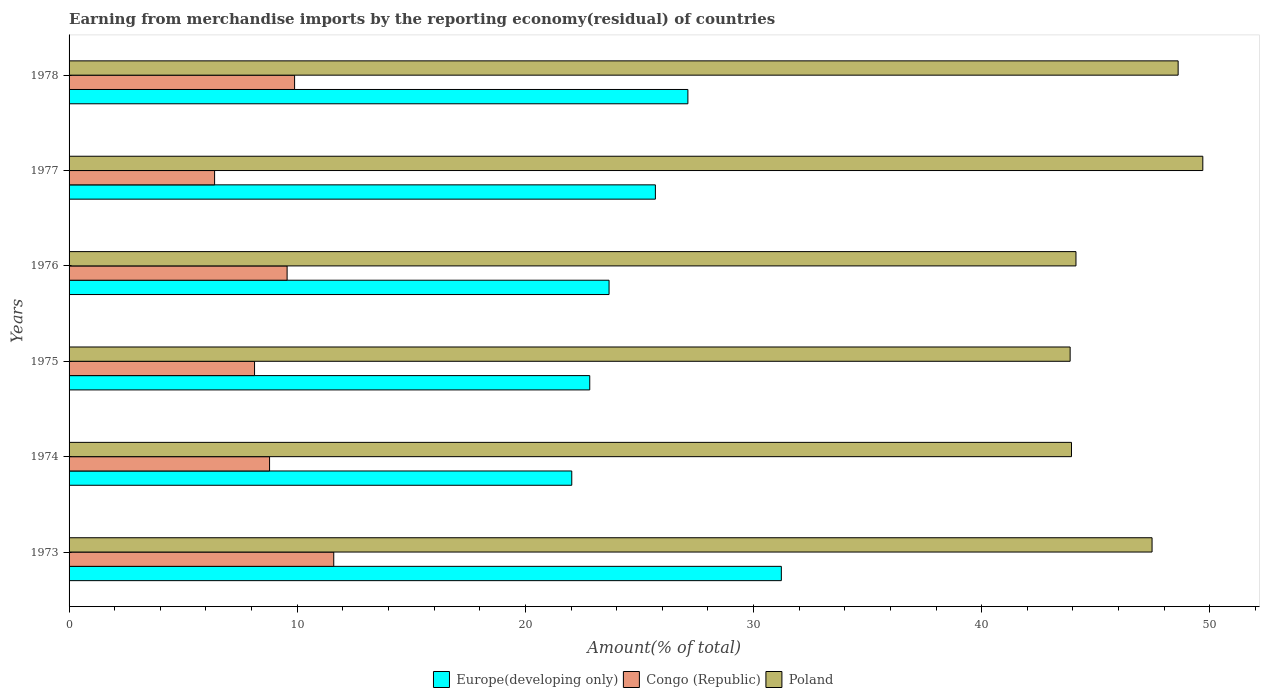How many bars are there on the 1st tick from the bottom?
Offer a very short reply. 3. What is the percentage of amount earned from merchandise imports in Congo (Republic) in 1973?
Keep it short and to the point. 11.6. Across all years, what is the maximum percentage of amount earned from merchandise imports in Poland?
Provide a succinct answer. 49.69. Across all years, what is the minimum percentage of amount earned from merchandise imports in Congo (Republic)?
Provide a succinct answer. 6.38. What is the total percentage of amount earned from merchandise imports in Europe(developing only) in the graph?
Make the answer very short. 152.57. What is the difference between the percentage of amount earned from merchandise imports in Europe(developing only) in 1976 and that in 1977?
Give a very brief answer. -2.03. What is the difference between the percentage of amount earned from merchandise imports in Europe(developing only) in 1977 and the percentage of amount earned from merchandise imports in Poland in 1973?
Provide a succinct answer. -21.77. What is the average percentage of amount earned from merchandise imports in Congo (Republic) per year?
Provide a succinct answer. 9.06. In the year 1977, what is the difference between the percentage of amount earned from merchandise imports in Congo (Republic) and percentage of amount earned from merchandise imports in Poland?
Give a very brief answer. -43.31. In how many years, is the percentage of amount earned from merchandise imports in Europe(developing only) greater than 8 %?
Provide a short and direct response. 6. What is the ratio of the percentage of amount earned from merchandise imports in Europe(developing only) in 1973 to that in 1974?
Offer a very short reply. 1.42. What is the difference between the highest and the second highest percentage of amount earned from merchandise imports in Europe(developing only)?
Provide a short and direct response. 4.1. What is the difference between the highest and the lowest percentage of amount earned from merchandise imports in Congo (Republic)?
Your response must be concise. 5.22. In how many years, is the percentage of amount earned from merchandise imports in Europe(developing only) greater than the average percentage of amount earned from merchandise imports in Europe(developing only) taken over all years?
Make the answer very short. 3. Is the sum of the percentage of amount earned from merchandise imports in Europe(developing only) in 1974 and 1977 greater than the maximum percentage of amount earned from merchandise imports in Congo (Republic) across all years?
Offer a terse response. Yes. What does the 2nd bar from the top in 1976 represents?
Make the answer very short. Congo (Republic). What does the 2nd bar from the bottom in 1974 represents?
Offer a terse response. Congo (Republic). Are all the bars in the graph horizontal?
Give a very brief answer. Yes. Does the graph contain grids?
Your response must be concise. No. Where does the legend appear in the graph?
Provide a short and direct response. Bottom center. What is the title of the graph?
Your answer should be very brief. Earning from merchandise imports by the reporting economy(residual) of countries. What is the label or title of the X-axis?
Your answer should be very brief. Amount(% of total). What is the label or title of the Y-axis?
Your response must be concise. Years. What is the Amount(% of total) in Europe(developing only) in 1973?
Your answer should be very brief. 31.22. What is the Amount(% of total) of Congo (Republic) in 1973?
Provide a succinct answer. 11.6. What is the Amount(% of total) in Poland in 1973?
Your response must be concise. 47.47. What is the Amount(% of total) of Europe(developing only) in 1974?
Your answer should be very brief. 22.03. What is the Amount(% of total) in Congo (Republic) in 1974?
Your answer should be very brief. 8.79. What is the Amount(% of total) of Poland in 1974?
Make the answer very short. 43.94. What is the Amount(% of total) of Europe(developing only) in 1975?
Ensure brevity in your answer.  22.82. What is the Amount(% of total) of Congo (Republic) in 1975?
Provide a succinct answer. 8.13. What is the Amount(% of total) in Poland in 1975?
Make the answer very short. 43.88. What is the Amount(% of total) in Europe(developing only) in 1976?
Offer a terse response. 23.67. What is the Amount(% of total) in Congo (Republic) in 1976?
Your response must be concise. 9.56. What is the Amount(% of total) of Poland in 1976?
Offer a very short reply. 44.13. What is the Amount(% of total) in Europe(developing only) in 1977?
Offer a very short reply. 25.7. What is the Amount(% of total) in Congo (Republic) in 1977?
Offer a very short reply. 6.38. What is the Amount(% of total) in Poland in 1977?
Your answer should be very brief. 49.69. What is the Amount(% of total) of Europe(developing only) in 1978?
Keep it short and to the point. 27.12. What is the Amount(% of total) in Congo (Republic) in 1978?
Make the answer very short. 9.88. What is the Amount(% of total) of Poland in 1978?
Make the answer very short. 48.61. Across all years, what is the maximum Amount(% of total) of Europe(developing only)?
Ensure brevity in your answer.  31.22. Across all years, what is the maximum Amount(% of total) of Congo (Republic)?
Keep it short and to the point. 11.6. Across all years, what is the maximum Amount(% of total) in Poland?
Offer a very short reply. 49.69. Across all years, what is the minimum Amount(% of total) in Europe(developing only)?
Provide a short and direct response. 22.03. Across all years, what is the minimum Amount(% of total) in Congo (Republic)?
Offer a very short reply. 6.38. Across all years, what is the minimum Amount(% of total) of Poland?
Your response must be concise. 43.88. What is the total Amount(% of total) in Europe(developing only) in the graph?
Keep it short and to the point. 152.57. What is the total Amount(% of total) of Congo (Republic) in the graph?
Offer a very short reply. 54.34. What is the total Amount(% of total) in Poland in the graph?
Your response must be concise. 277.72. What is the difference between the Amount(% of total) of Europe(developing only) in 1973 and that in 1974?
Your response must be concise. 9.19. What is the difference between the Amount(% of total) in Congo (Republic) in 1973 and that in 1974?
Ensure brevity in your answer.  2.81. What is the difference between the Amount(% of total) of Poland in 1973 and that in 1974?
Make the answer very short. 3.53. What is the difference between the Amount(% of total) in Europe(developing only) in 1973 and that in 1975?
Offer a very short reply. 8.4. What is the difference between the Amount(% of total) of Congo (Republic) in 1973 and that in 1975?
Provide a succinct answer. 3.47. What is the difference between the Amount(% of total) in Poland in 1973 and that in 1975?
Your response must be concise. 3.59. What is the difference between the Amount(% of total) in Europe(developing only) in 1973 and that in 1976?
Your answer should be very brief. 7.55. What is the difference between the Amount(% of total) in Congo (Republic) in 1973 and that in 1976?
Keep it short and to the point. 2.04. What is the difference between the Amount(% of total) in Poland in 1973 and that in 1976?
Your response must be concise. 3.34. What is the difference between the Amount(% of total) of Europe(developing only) in 1973 and that in 1977?
Make the answer very short. 5.52. What is the difference between the Amount(% of total) in Congo (Republic) in 1973 and that in 1977?
Offer a very short reply. 5.22. What is the difference between the Amount(% of total) of Poland in 1973 and that in 1977?
Your answer should be compact. -2.22. What is the difference between the Amount(% of total) of Europe(developing only) in 1973 and that in 1978?
Offer a terse response. 4.1. What is the difference between the Amount(% of total) of Congo (Republic) in 1973 and that in 1978?
Make the answer very short. 1.72. What is the difference between the Amount(% of total) in Poland in 1973 and that in 1978?
Make the answer very short. -1.14. What is the difference between the Amount(% of total) in Europe(developing only) in 1974 and that in 1975?
Provide a short and direct response. -0.79. What is the difference between the Amount(% of total) in Congo (Republic) in 1974 and that in 1975?
Your response must be concise. 0.66. What is the difference between the Amount(% of total) in Poland in 1974 and that in 1975?
Make the answer very short. 0.06. What is the difference between the Amount(% of total) in Europe(developing only) in 1974 and that in 1976?
Give a very brief answer. -1.63. What is the difference between the Amount(% of total) of Congo (Republic) in 1974 and that in 1976?
Ensure brevity in your answer.  -0.77. What is the difference between the Amount(% of total) in Poland in 1974 and that in 1976?
Make the answer very short. -0.2. What is the difference between the Amount(% of total) of Europe(developing only) in 1974 and that in 1977?
Your answer should be compact. -3.67. What is the difference between the Amount(% of total) of Congo (Republic) in 1974 and that in 1977?
Provide a succinct answer. 2.41. What is the difference between the Amount(% of total) of Poland in 1974 and that in 1977?
Offer a very short reply. -5.76. What is the difference between the Amount(% of total) of Europe(developing only) in 1974 and that in 1978?
Ensure brevity in your answer.  -5.09. What is the difference between the Amount(% of total) of Congo (Republic) in 1974 and that in 1978?
Offer a very short reply. -1.1. What is the difference between the Amount(% of total) in Poland in 1974 and that in 1978?
Give a very brief answer. -4.68. What is the difference between the Amount(% of total) of Europe(developing only) in 1975 and that in 1976?
Keep it short and to the point. -0.85. What is the difference between the Amount(% of total) of Congo (Republic) in 1975 and that in 1976?
Offer a terse response. -1.43. What is the difference between the Amount(% of total) of Poland in 1975 and that in 1976?
Provide a short and direct response. -0.26. What is the difference between the Amount(% of total) of Europe(developing only) in 1975 and that in 1977?
Offer a terse response. -2.88. What is the difference between the Amount(% of total) of Congo (Republic) in 1975 and that in 1977?
Offer a very short reply. 1.75. What is the difference between the Amount(% of total) of Poland in 1975 and that in 1977?
Give a very brief answer. -5.81. What is the difference between the Amount(% of total) in Europe(developing only) in 1975 and that in 1978?
Provide a succinct answer. -4.3. What is the difference between the Amount(% of total) in Congo (Republic) in 1975 and that in 1978?
Make the answer very short. -1.76. What is the difference between the Amount(% of total) of Poland in 1975 and that in 1978?
Keep it short and to the point. -4.73. What is the difference between the Amount(% of total) in Europe(developing only) in 1976 and that in 1977?
Keep it short and to the point. -2.03. What is the difference between the Amount(% of total) of Congo (Republic) in 1976 and that in 1977?
Make the answer very short. 3.18. What is the difference between the Amount(% of total) of Poland in 1976 and that in 1977?
Provide a short and direct response. -5.56. What is the difference between the Amount(% of total) in Europe(developing only) in 1976 and that in 1978?
Keep it short and to the point. -3.46. What is the difference between the Amount(% of total) in Congo (Republic) in 1976 and that in 1978?
Offer a very short reply. -0.33. What is the difference between the Amount(% of total) in Poland in 1976 and that in 1978?
Your response must be concise. -4.48. What is the difference between the Amount(% of total) of Europe(developing only) in 1977 and that in 1978?
Your answer should be very brief. -1.42. What is the difference between the Amount(% of total) of Congo (Republic) in 1977 and that in 1978?
Give a very brief answer. -3.51. What is the difference between the Amount(% of total) of Poland in 1977 and that in 1978?
Your response must be concise. 1.08. What is the difference between the Amount(% of total) in Europe(developing only) in 1973 and the Amount(% of total) in Congo (Republic) in 1974?
Offer a very short reply. 22.43. What is the difference between the Amount(% of total) in Europe(developing only) in 1973 and the Amount(% of total) in Poland in 1974?
Your answer should be very brief. -12.72. What is the difference between the Amount(% of total) of Congo (Republic) in 1973 and the Amount(% of total) of Poland in 1974?
Your answer should be compact. -32.34. What is the difference between the Amount(% of total) in Europe(developing only) in 1973 and the Amount(% of total) in Congo (Republic) in 1975?
Your answer should be compact. 23.09. What is the difference between the Amount(% of total) of Europe(developing only) in 1973 and the Amount(% of total) of Poland in 1975?
Provide a succinct answer. -12.66. What is the difference between the Amount(% of total) of Congo (Republic) in 1973 and the Amount(% of total) of Poland in 1975?
Your response must be concise. -32.28. What is the difference between the Amount(% of total) in Europe(developing only) in 1973 and the Amount(% of total) in Congo (Republic) in 1976?
Your answer should be compact. 21.66. What is the difference between the Amount(% of total) in Europe(developing only) in 1973 and the Amount(% of total) in Poland in 1976?
Keep it short and to the point. -12.91. What is the difference between the Amount(% of total) in Congo (Republic) in 1973 and the Amount(% of total) in Poland in 1976?
Keep it short and to the point. -32.53. What is the difference between the Amount(% of total) in Europe(developing only) in 1973 and the Amount(% of total) in Congo (Republic) in 1977?
Your response must be concise. 24.84. What is the difference between the Amount(% of total) in Europe(developing only) in 1973 and the Amount(% of total) in Poland in 1977?
Provide a succinct answer. -18.47. What is the difference between the Amount(% of total) of Congo (Republic) in 1973 and the Amount(% of total) of Poland in 1977?
Give a very brief answer. -38.09. What is the difference between the Amount(% of total) of Europe(developing only) in 1973 and the Amount(% of total) of Congo (Republic) in 1978?
Your answer should be compact. 21.34. What is the difference between the Amount(% of total) of Europe(developing only) in 1973 and the Amount(% of total) of Poland in 1978?
Keep it short and to the point. -17.39. What is the difference between the Amount(% of total) in Congo (Republic) in 1973 and the Amount(% of total) in Poland in 1978?
Offer a terse response. -37.01. What is the difference between the Amount(% of total) in Europe(developing only) in 1974 and the Amount(% of total) in Congo (Republic) in 1975?
Give a very brief answer. 13.9. What is the difference between the Amount(% of total) in Europe(developing only) in 1974 and the Amount(% of total) in Poland in 1975?
Keep it short and to the point. -21.84. What is the difference between the Amount(% of total) of Congo (Republic) in 1974 and the Amount(% of total) of Poland in 1975?
Keep it short and to the point. -35.09. What is the difference between the Amount(% of total) in Europe(developing only) in 1974 and the Amount(% of total) in Congo (Republic) in 1976?
Offer a very short reply. 12.48. What is the difference between the Amount(% of total) of Europe(developing only) in 1974 and the Amount(% of total) of Poland in 1976?
Give a very brief answer. -22.1. What is the difference between the Amount(% of total) of Congo (Republic) in 1974 and the Amount(% of total) of Poland in 1976?
Make the answer very short. -35.35. What is the difference between the Amount(% of total) in Europe(developing only) in 1974 and the Amount(% of total) in Congo (Republic) in 1977?
Offer a very short reply. 15.66. What is the difference between the Amount(% of total) in Europe(developing only) in 1974 and the Amount(% of total) in Poland in 1977?
Provide a short and direct response. -27.66. What is the difference between the Amount(% of total) in Congo (Republic) in 1974 and the Amount(% of total) in Poland in 1977?
Keep it short and to the point. -40.91. What is the difference between the Amount(% of total) in Europe(developing only) in 1974 and the Amount(% of total) in Congo (Republic) in 1978?
Provide a succinct answer. 12.15. What is the difference between the Amount(% of total) of Europe(developing only) in 1974 and the Amount(% of total) of Poland in 1978?
Offer a terse response. -26.58. What is the difference between the Amount(% of total) of Congo (Republic) in 1974 and the Amount(% of total) of Poland in 1978?
Offer a very short reply. -39.82. What is the difference between the Amount(% of total) in Europe(developing only) in 1975 and the Amount(% of total) in Congo (Republic) in 1976?
Give a very brief answer. 13.27. What is the difference between the Amount(% of total) in Europe(developing only) in 1975 and the Amount(% of total) in Poland in 1976?
Your response must be concise. -21.31. What is the difference between the Amount(% of total) in Congo (Republic) in 1975 and the Amount(% of total) in Poland in 1976?
Provide a short and direct response. -36. What is the difference between the Amount(% of total) of Europe(developing only) in 1975 and the Amount(% of total) of Congo (Republic) in 1977?
Your response must be concise. 16.44. What is the difference between the Amount(% of total) of Europe(developing only) in 1975 and the Amount(% of total) of Poland in 1977?
Your answer should be very brief. -26.87. What is the difference between the Amount(% of total) in Congo (Republic) in 1975 and the Amount(% of total) in Poland in 1977?
Your response must be concise. -41.56. What is the difference between the Amount(% of total) in Europe(developing only) in 1975 and the Amount(% of total) in Congo (Republic) in 1978?
Your answer should be compact. 12.94. What is the difference between the Amount(% of total) of Europe(developing only) in 1975 and the Amount(% of total) of Poland in 1978?
Your response must be concise. -25.79. What is the difference between the Amount(% of total) of Congo (Republic) in 1975 and the Amount(% of total) of Poland in 1978?
Provide a short and direct response. -40.48. What is the difference between the Amount(% of total) of Europe(developing only) in 1976 and the Amount(% of total) of Congo (Republic) in 1977?
Keep it short and to the point. 17.29. What is the difference between the Amount(% of total) of Europe(developing only) in 1976 and the Amount(% of total) of Poland in 1977?
Make the answer very short. -26.02. What is the difference between the Amount(% of total) of Congo (Republic) in 1976 and the Amount(% of total) of Poland in 1977?
Your answer should be very brief. -40.14. What is the difference between the Amount(% of total) of Europe(developing only) in 1976 and the Amount(% of total) of Congo (Republic) in 1978?
Offer a very short reply. 13.78. What is the difference between the Amount(% of total) in Europe(developing only) in 1976 and the Amount(% of total) in Poland in 1978?
Offer a terse response. -24.94. What is the difference between the Amount(% of total) of Congo (Republic) in 1976 and the Amount(% of total) of Poland in 1978?
Keep it short and to the point. -39.06. What is the difference between the Amount(% of total) of Europe(developing only) in 1977 and the Amount(% of total) of Congo (Republic) in 1978?
Provide a succinct answer. 15.81. What is the difference between the Amount(% of total) of Europe(developing only) in 1977 and the Amount(% of total) of Poland in 1978?
Your response must be concise. -22.91. What is the difference between the Amount(% of total) of Congo (Republic) in 1977 and the Amount(% of total) of Poland in 1978?
Provide a succinct answer. -42.23. What is the average Amount(% of total) of Europe(developing only) per year?
Make the answer very short. 25.43. What is the average Amount(% of total) of Congo (Republic) per year?
Ensure brevity in your answer.  9.06. What is the average Amount(% of total) in Poland per year?
Provide a short and direct response. 46.29. In the year 1973, what is the difference between the Amount(% of total) in Europe(developing only) and Amount(% of total) in Congo (Republic)?
Offer a very short reply. 19.62. In the year 1973, what is the difference between the Amount(% of total) in Europe(developing only) and Amount(% of total) in Poland?
Provide a succinct answer. -16.25. In the year 1973, what is the difference between the Amount(% of total) of Congo (Republic) and Amount(% of total) of Poland?
Ensure brevity in your answer.  -35.87. In the year 1974, what is the difference between the Amount(% of total) in Europe(developing only) and Amount(% of total) in Congo (Republic)?
Your response must be concise. 13.25. In the year 1974, what is the difference between the Amount(% of total) of Europe(developing only) and Amount(% of total) of Poland?
Keep it short and to the point. -21.9. In the year 1974, what is the difference between the Amount(% of total) of Congo (Republic) and Amount(% of total) of Poland?
Provide a short and direct response. -35.15. In the year 1975, what is the difference between the Amount(% of total) in Europe(developing only) and Amount(% of total) in Congo (Republic)?
Provide a succinct answer. 14.69. In the year 1975, what is the difference between the Amount(% of total) of Europe(developing only) and Amount(% of total) of Poland?
Offer a terse response. -21.06. In the year 1975, what is the difference between the Amount(% of total) of Congo (Republic) and Amount(% of total) of Poland?
Your response must be concise. -35.75. In the year 1976, what is the difference between the Amount(% of total) in Europe(developing only) and Amount(% of total) in Congo (Republic)?
Keep it short and to the point. 14.11. In the year 1976, what is the difference between the Amount(% of total) in Europe(developing only) and Amount(% of total) in Poland?
Give a very brief answer. -20.47. In the year 1976, what is the difference between the Amount(% of total) in Congo (Republic) and Amount(% of total) in Poland?
Your answer should be compact. -34.58. In the year 1977, what is the difference between the Amount(% of total) of Europe(developing only) and Amount(% of total) of Congo (Republic)?
Offer a terse response. 19.32. In the year 1977, what is the difference between the Amount(% of total) in Europe(developing only) and Amount(% of total) in Poland?
Give a very brief answer. -23.99. In the year 1977, what is the difference between the Amount(% of total) in Congo (Republic) and Amount(% of total) in Poland?
Your answer should be compact. -43.31. In the year 1978, what is the difference between the Amount(% of total) of Europe(developing only) and Amount(% of total) of Congo (Republic)?
Your answer should be compact. 17.24. In the year 1978, what is the difference between the Amount(% of total) in Europe(developing only) and Amount(% of total) in Poland?
Offer a terse response. -21.49. In the year 1978, what is the difference between the Amount(% of total) of Congo (Republic) and Amount(% of total) of Poland?
Your answer should be very brief. -38.73. What is the ratio of the Amount(% of total) in Europe(developing only) in 1973 to that in 1974?
Give a very brief answer. 1.42. What is the ratio of the Amount(% of total) in Congo (Republic) in 1973 to that in 1974?
Your answer should be very brief. 1.32. What is the ratio of the Amount(% of total) of Poland in 1973 to that in 1974?
Offer a terse response. 1.08. What is the ratio of the Amount(% of total) in Europe(developing only) in 1973 to that in 1975?
Ensure brevity in your answer.  1.37. What is the ratio of the Amount(% of total) in Congo (Republic) in 1973 to that in 1975?
Offer a very short reply. 1.43. What is the ratio of the Amount(% of total) of Poland in 1973 to that in 1975?
Offer a very short reply. 1.08. What is the ratio of the Amount(% of total) of Europe(developing only) in 1973 to that in 1976?
Your answer should be compact. 1.32. What is the ratio of the Amount(% of total) in Congo (Republic) in 1973 to that in 1976?
Ensure brevity in your answer.  1.21. What is the ratio of the Amount(% of total) of Poland in 1973 to that in 1976?
Your answer should be very brief. 1.08. What is the ratio of the Amount(% of total) in Europe(developing only) in 1973 to that in 1977?
Keep it short and to the point. 1.21. What is the ratio of the Amount(% of total) of Congo (Republic) in 1973 to that in 1977?
Your response must be concise. 1.82. What is the ratio of the Amount(% of total) of Poland in 1973 to that in 1977?
Ensure brevity in your answer.  0.96. What is the ratio of the Amount(% of total) of Europe(developing only) in 1973 to that in 1978?
Give a very brief answer. 1.15. What is the ratio of the Amount(% of total) in Congo (Republic) in 1973 to that in 1978?
Offer a very short reply. 1.17. What is the ratio of the Amount(% of total) of Poland in 1973 to that in 1978?
Offer a very short reply. 0.98. What is the ratio of the Amount(% of total) of Europe(developing only) in 1974 to that in 1975?
Provide a short and direct response. 0.97. What is the ratio of the Amount(% of total) of Congo (Republic) in 1974 to that in 1975?
Your answer should be compact. 1.08. What is the ratio of the Amount(% of total) in Europe(developing only) in 1974 to that in 1976?
Offer a very short reply. 0.93. What is the ratio of the Amount(% of total) of Congo (Republic) in 1974 to that in 1976?
Offer a very short reply. 0.92. What is the ratio of the Amount(% of total) in Europe(developing only) in 1974 to that in 1977?
Offer a terse response. 0.86. What is the ratio of the Amount(% of total) in Congo (Republic) in 1974 to that in 1977?
Your response must be concise. 1.38. What is the ratio of the Amount(% of total) in Poland in 1974 to that in 1977?
Give a very brief answer. 0.88. What is the ratio of the Amount(% of total) in Europe(developing only) in 1974 to that in 1978?
Ensure brevity in your answer.  0.81. What is the ratio of the Amount(% of total) in Congo (Republic) in 1974 to that in 1978?
Your answer should be very brief. 0.89. What is the ratio of the Amount(% of total) in Poland in 1974 to that in 1978?
Offer a terse response. 0.9. What is the ratio of the Amount(% of total) in Congo (Republic) in 1975 to that in 1976?
Your response must be concise. 0.85. What is the ratio of the Amount(% of total) of Europe(developing only) in 1975 to that in 1977?
Your response must be concise. 0.89. What is the ratio of the Amount(% of total) of Congo (Republic) in 1975 to that in 1977?
Give a very brief answer. 1.27. What is the ratio of the Amount(% of total) of Poland in 1975 to that in 1977?
Offer a very short reply. 0.88. What is the ratio of the Amount(% of total) in Europe(developing only) in 1975 to that in 1978?
Your answer should be compact. 0.84. What is the ratio of the Amount(% of total) of Congo (Republic) in 1975 to that in 1978?
Offer a terse response. 0.82. What is the ratio of the Amount(% of total) of Poland in 1975 to that in 1978?
Your answer should be compact. 0.9. What is the ratio of the Amount(% of total) in Europe(developing only) in 1976 to that in 1977?
Give a very brief answer. 0.92. What is the ratio of the Amount(% of total) in Congo (Republic) in 1976 to that in 1977?
Provide a short and direct response. 1.5. What is the ratio of the Amount(% of total) of Poland in 1976 to that in 1977?
Offer a very short reply. 0.89. What is the ratio of the Amount(% of total) of Europe(developing only) in 1976 to that in 1978?
Your answer should be very brief. 0.87. What is the ratio of the Amount(% of total) of Congo (Republic) in 1976 to that in 1978?
Provide a short and direct response. 0.97. What is the ratio of the Amount(% of total) of Poland in 1976 to that in 1978?
Your answer should be compact. 0.91. What is the ratio of the Amount(% of total) in Europe(developing only) in 1977 to that in 1978?
Offer a very short reply. 0.95. What is the ratio of the Amount(% of total) in Congo (Republic) in 1977 to that in 1978?
Your answer should be compact. 0.65. What is the ratio of the Amount(% of total) of Poland in 1977 to that in 1978?
Make the answer very short. 1.02. What is the difference between the highest and the second highest Amount(% of total) in Europe(developing only)?
Offer a terse response. 4.1. What is the difference between the highest and the second highest Amount(% of total) of Congo (Republic)?
Offer a very short reply. 1.72. What is the difference between the highest and the second highest Amount(% of total) in Poland?
Your answer should be compact. 1.08. What is the difference between the highest and the lowest Amount(% of total) of Europe(developing only)?
Provide a succinct answer. 9.19. What is the difference between the highest and the lowest Amount(% of total) in Congo (Republic)?
Offer a very short reply. 5.22. What is the difference between the highest and the lowest Amount(% of total) of Poland?
Your response must be concise. 5.81. 